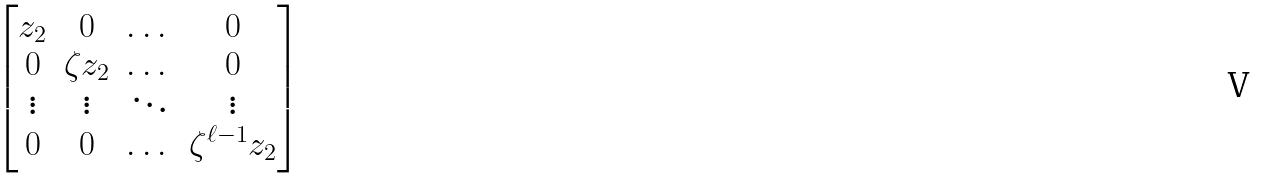Convert formula to latex. <formula><loc_0><loc_0><loc_500><loc_500>\begin{bmatrix} z _ { 2 } & 0 & \dots & 0 \\ 0 & \zeta z _ { 2 } & \dots & 0 \\ \vdots & \vdots & \ddots & \vdots \\ 0 & 0 & \dots & \zeta ^ { \ell - 1 } z _ { 2 } \end{bmatrix}</formula> 